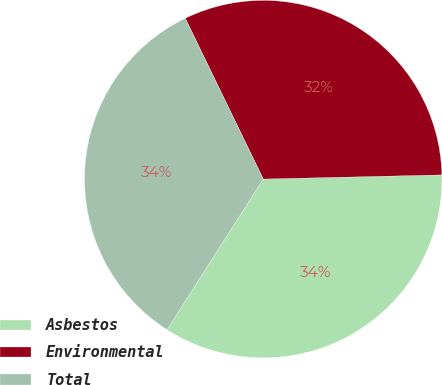<chart> <loc_0><loc_0><loc_500><loc_500><pie_chart><fcel>Asbestos<fcel>Environmental<fcel>Total<nl><fcel>34.42%<fcel>31.82%<fcel>33.77%<nl></chart> 